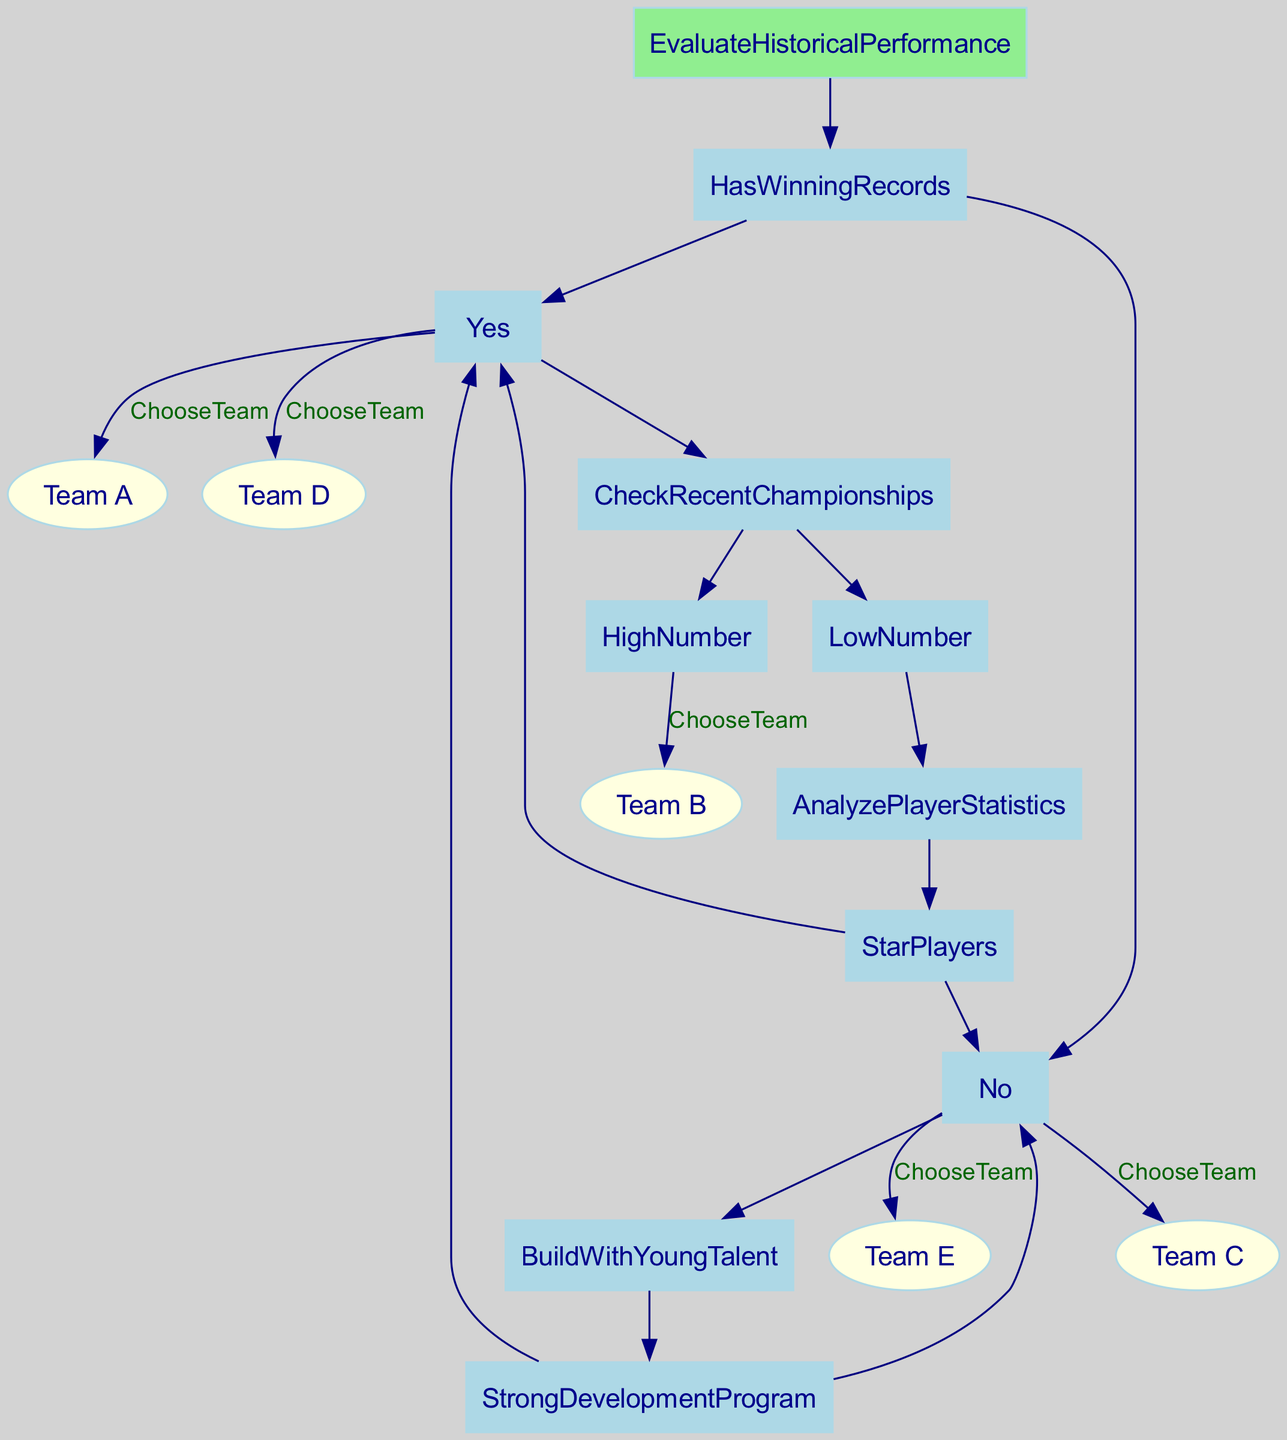What are the two main branches after evaluating historical performance? The first branch is "Has Winning Records", and the second is "No". "Has Winning Records" leads to a further evaluation of recent championships, while "No" leads to assessing the development of young talent.
Answer: Has Winning Records, No Which team is chosen if there is a high number of recent championships? If the evaluation of recent championships indicates a high number, the decision tree specifies "Choose Team B" directly as the outcome.
Answer: Team B How many teams are there in total that can be chosen based on this decision tree? The decision tree has five potential teams that can be chosen: Team A, Team B, Team C, Team D, and Team E.
Answer: Five What do you analyze if the historical performance indicates winning records but a low number of recent championships? In this scenario, the next step is to analyze player statistics, specifically focusing on whether the team has star players or not.
Answer: Analyze Player Statistics What happens to Team D in the decision-making process? If the evaluation shows there is no winning record but a strong development program, the decision tree leads to choosing Team D as a favorable team.
Answer: Choose Team D What is the fate of teams when there are 'No' winning records and a 'No' for a strong development program? If both conditions are true, the decision tree specifies selecting Team E in this case.
Answer: Choose Team E Which choice is made when historical performance shows winning records and star players are present? The decision tree indicates that the choice would be Team A if the historical performance shows winning records and there are star players.
Answer: Team A What node follows after confirming a low number of recent championships in the decision process? After confirming a low number of recent championships, the decision tree directs to the analysis of player statistics next.
Answer: Analyze Player Statistics Which condition leads to selecting Team C? Selecting Team C occurs if the historical performance indicates winning records, there are low recent championships, and no star players are present.
Answer: No Star Players 